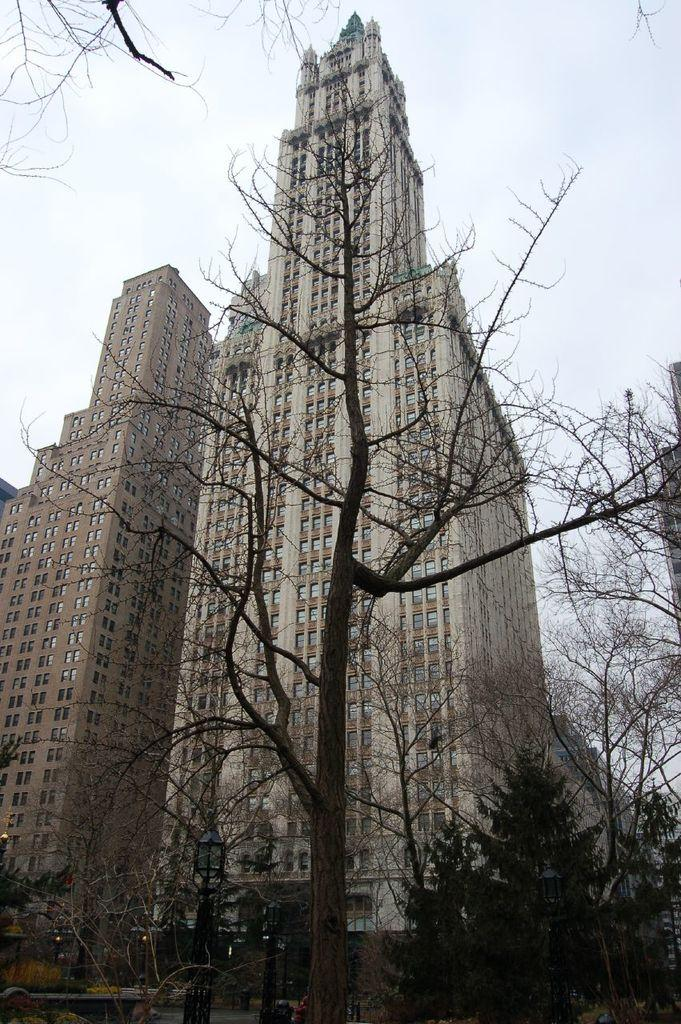What type of natural elements can be seen in the image? There are trees in the image. What artificial elements can be seen in the image? There are lights and buildings in the image. What is visible in the background of the image? The sky is clear and visible in the background of the image. What type of fork can be seen in the image? There is no fork present in the image. What is the taste of the volcano in the image? There is no volcano present in the image, so it cannot be tasted. 